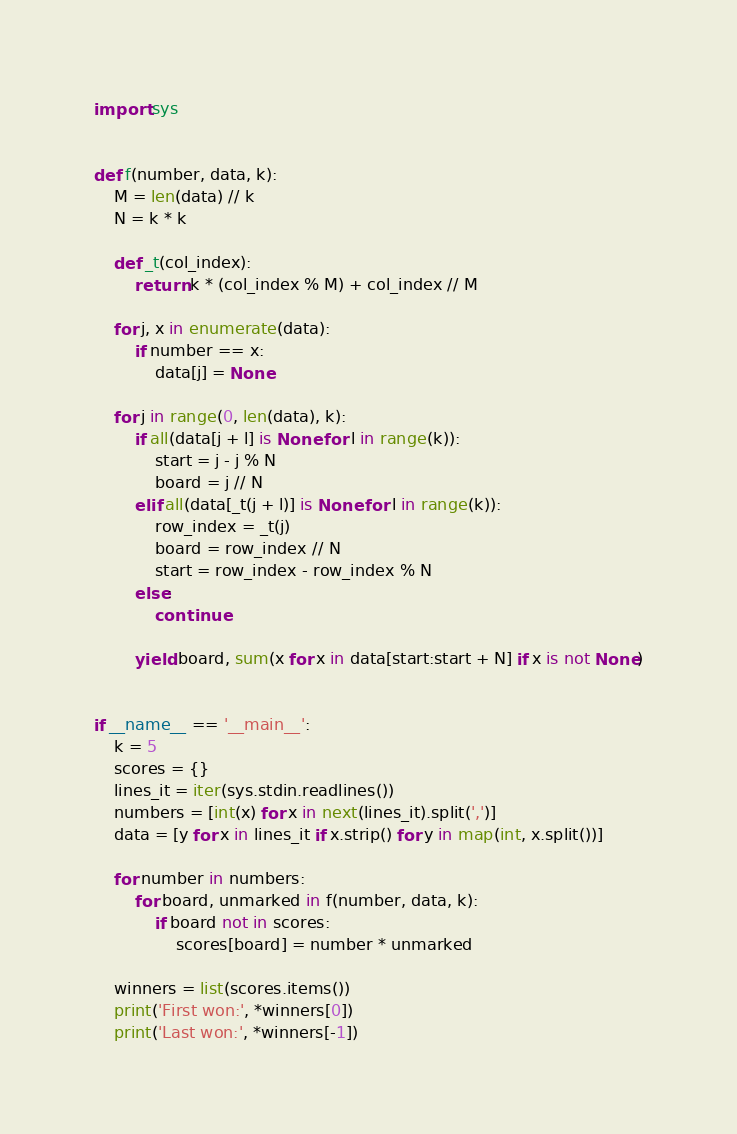Convert code to text. <code><loc_0><loc_0><loc_500><loc_500><_Python_>import sys


def f(number, data, k):
    M = len(data) // k
    N = k * k

    def _t(col_index):
        return k * (col_index % M) + col_index // M

    for j, x in enumerate(data):
        if number == x:
            data[j] = None

    for j in range(0, len(data), k):
        if all(data[j + l] is None for l in range(k)):
            start = j - j % N
            board = j // N
        elif all(data[_t(j + l)] is None for l in range(k)):
            row_index = _t(j)
            board = row_index // N
            start = row_index - row_index % N
        else:
            continue

        yield board, sum(x for x in data[start:start + N] if x is not None)


if __name__ == '__main__':
    k = 5
    scores = {}
    lines_it = iter(sys.stdin.readlines())
    numbers = [int(x) for x in next(lines_it).split(',')]
    data = [y for x in lines_it if x.strip() for y in map(int, x.split())]

    for number in numbers:
        for board, unmarked in f(number, data, k):
            if board not in scores:
                scores[board] = number * unmarked

    winners = list(scores.items())
    print('First won:', *winners[0])
    print('Last won:', *winners[-1])
</code> 